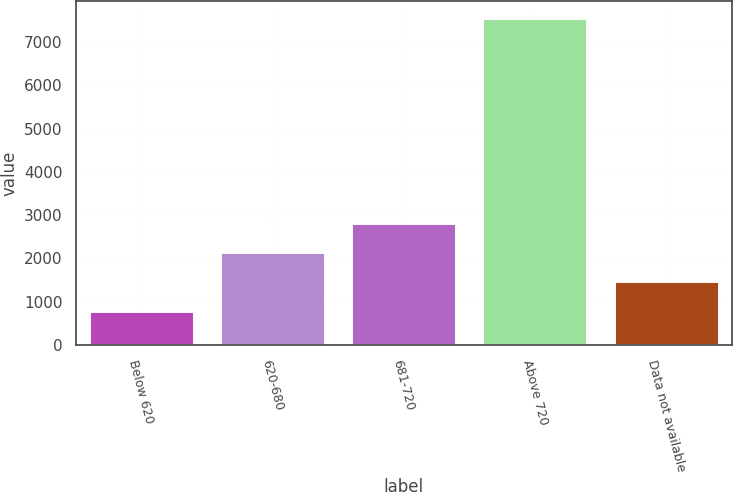<chart> <loc_0><loc_0><loc_500><loc_500><bar_chart><fcel>Below 620<fcel>620-680<fcel>681-720<fcel>Above 720<fcel>Data not available<nl><fcel>789<fcel>2143.4<fcel>2820.6<fcel>7561<fcel>1466.2<nl></chart> 